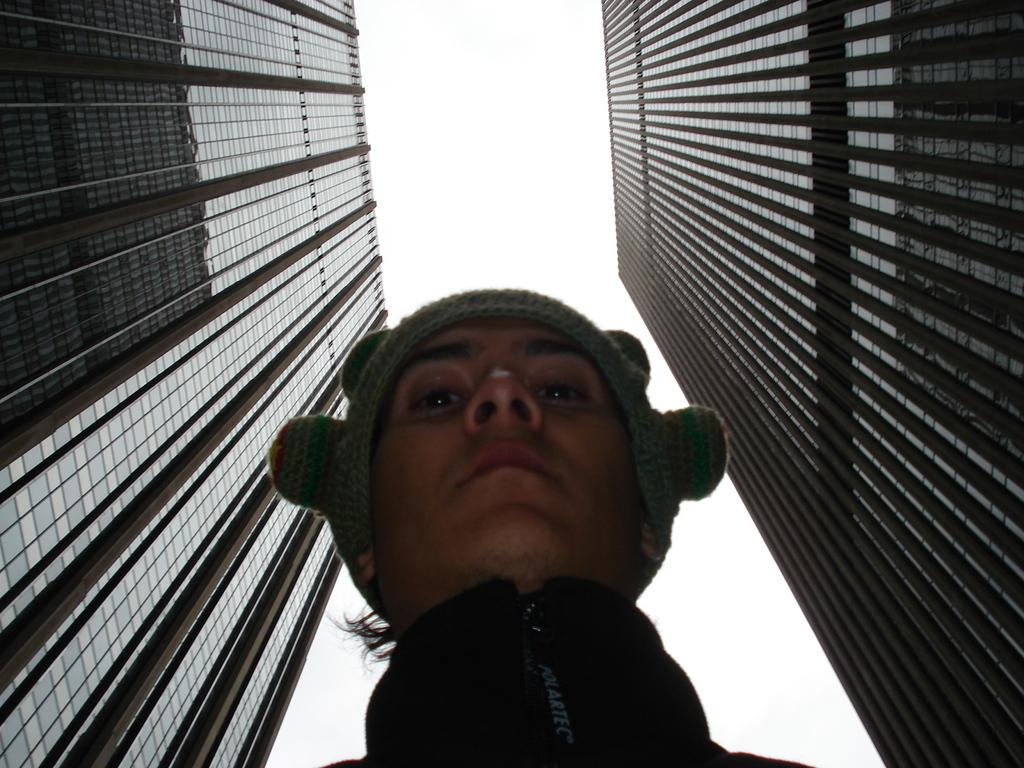Who or what is the main subject in the center of the image? There is a person in the center of the image. What type of structures can be seen on the right side of the image? There are buildings on the right side of the image. What type of structures can be seen on the left side of the image? There are buildings on the left side of the image. What can be seen in the background of the image? The sky is visible in the background of the image. What type of game is being played by the carpenter in the image? There is no carpenter or game present in the image. How many cents are visible in the image? There are no cents visible in the image. 